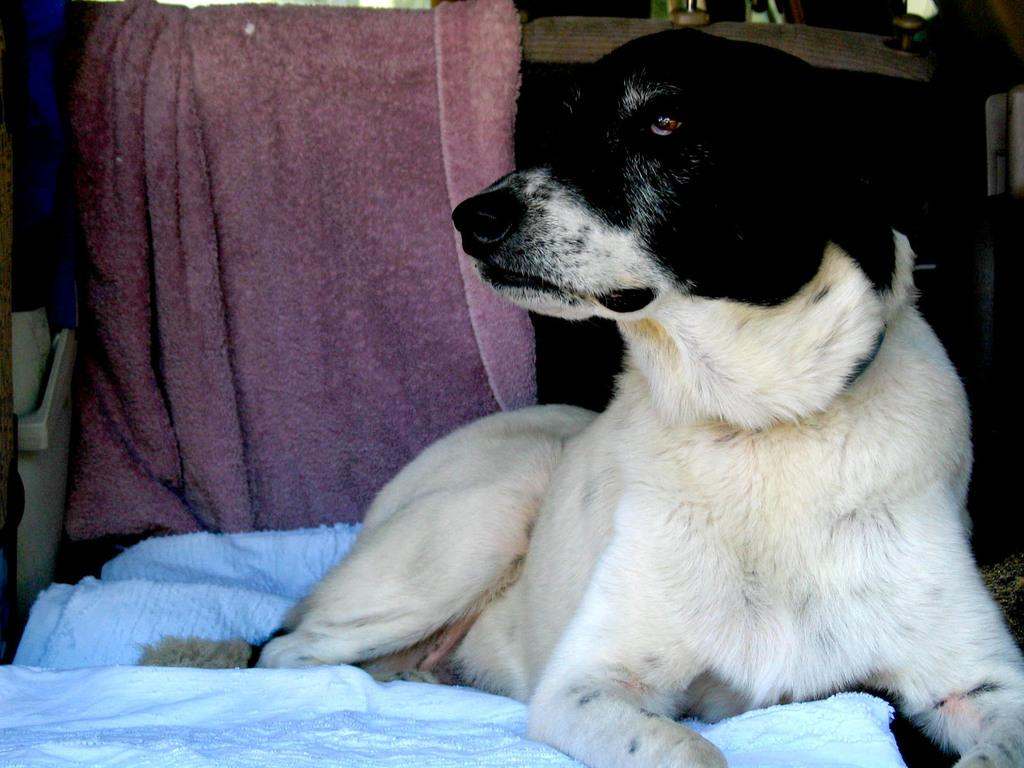What animal is present in the image? There is a dog in the image. What is the dog sitting on? The dog is sitting on a white towel. Can you describe the color pattern of the dog? The dog has a white and black color pattern. What other towel can be seen in the image? There is a pink towel in the background of the image. What type of soup is being served in the vase in the image? There is no vase or soup present in the image; it features a dog sitting on a white towel. Can you recite a verse that is written on the pink towel in the image? There is no verse written on the pink towel in the image; it is simply a towel in the background. 